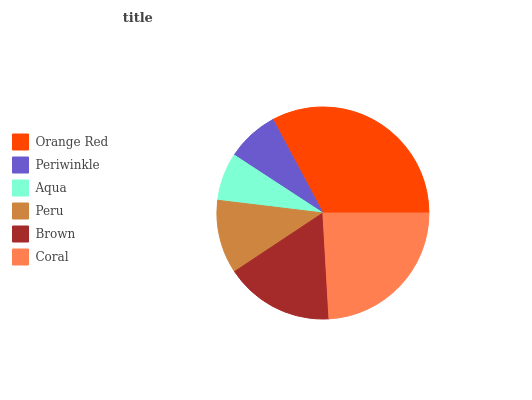Is Aqua the minimum?
Answer yes or no. Yes. Is Orange Red the maximum?
Answer yes or no. Yes. Is Periwinkle the minimum?
Answer yes or no. No. Is Periwinkle the maximum?
Answer yes or no. No. Is Orange Red greater than Periwinkle?
Answer yes or no. Yes. Is Periwinkle less than Orange Red?
Answer yes or no. Yes. Is Periwinkle greater than Orange Red?
Answer yes or no. No. Is Orange Red less than Periwinkle?
Answer yes or no. No. Is Brown the high median?
Answer yes or no. Yes. Is Peru the low median?
Answer yes or no. Yes. Is Aqua the high median?
Answer yes or no. No. Is Orange Red the low median?
Answer yes or no. No. 